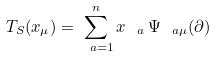Convert formula to latex. <formula><loc_0><loc_0><loc_500><loc_500>T _ { S } ( x _ { \mu } ) = \sum _ { \ a = 1 } ^ { n } x _ { \ a } \, \Psi _ { \ a \mu } ( \partial )</formula> 